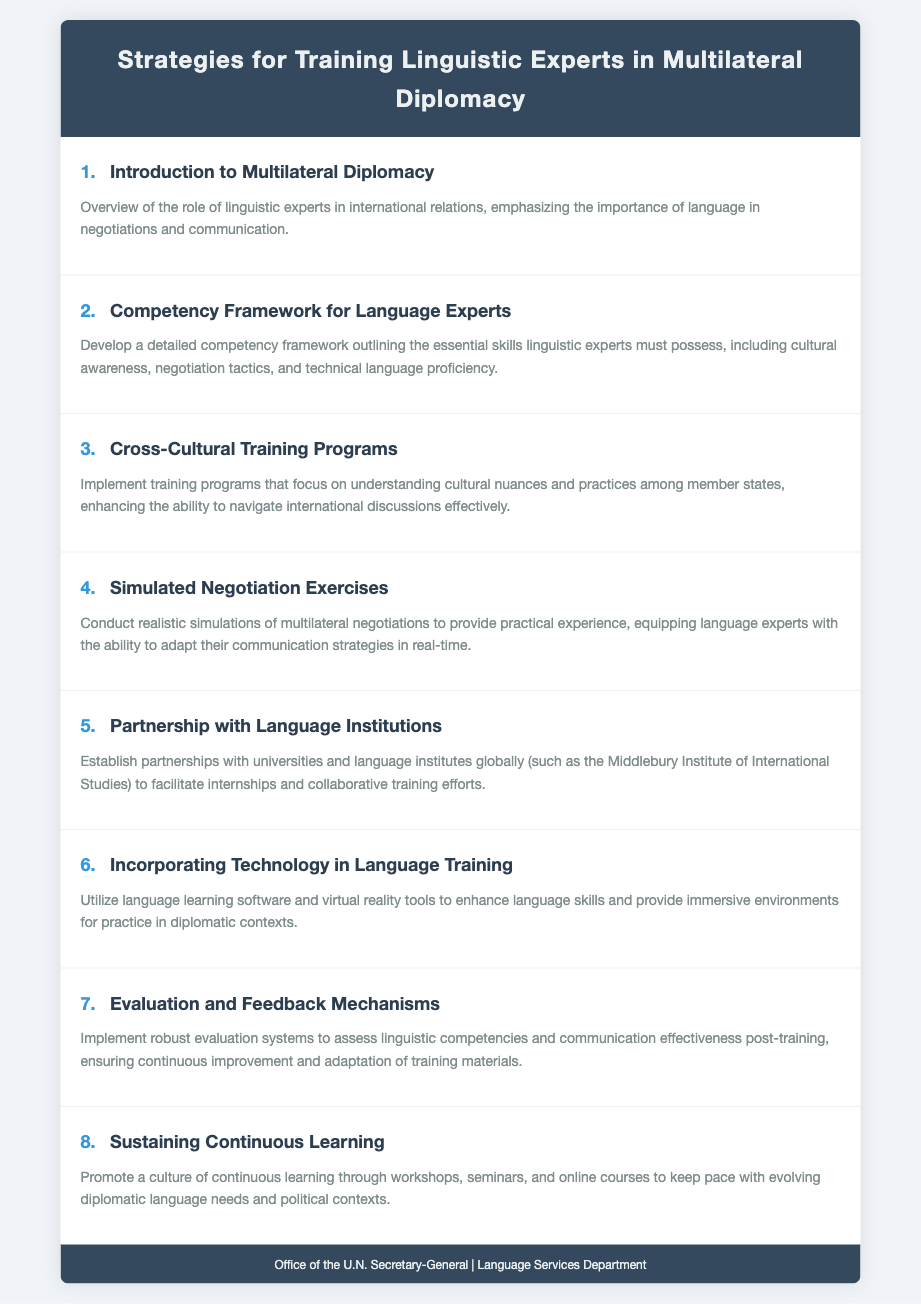What is the title of the document? The title of the document is presented in the header section of the agenda.
Answer: Strategies for Training Linguistic Experts in Multilateral Diplomacy How many agenda items are listed? The total number of agenda items can be counted from the list in the document.
Answer: 8 What is the focus of the second agenda item? The second agenda item outlines specific competencies required for linguistic experts.
Answer: Competency Framework for Language Experts Which training method is mentioned in agenda item four? The fourth item discusses a type of practical experience for language experts.
Answer: Simulated Negotiation Exercises What is emphasized in the third agenda item? The need for understanding cultural differences is highlighted in this item.
Answer: Cross-Cultural Training Programs Which institution is mentioned for partnerships in training? The document lists a specific type of institution for partnership in the fifth agenda item.
Answer: Middlebury Institute of International Studies What tool is suggested for enhancing language skills? The sixth agenda item mentions specific technological tools for training.
Answer: Virtual reality tools What is the goal of the last agenda item? The purpose of the last item is focused on ongoing education and skill development.
Answer: Sustaining Continuous Learning 